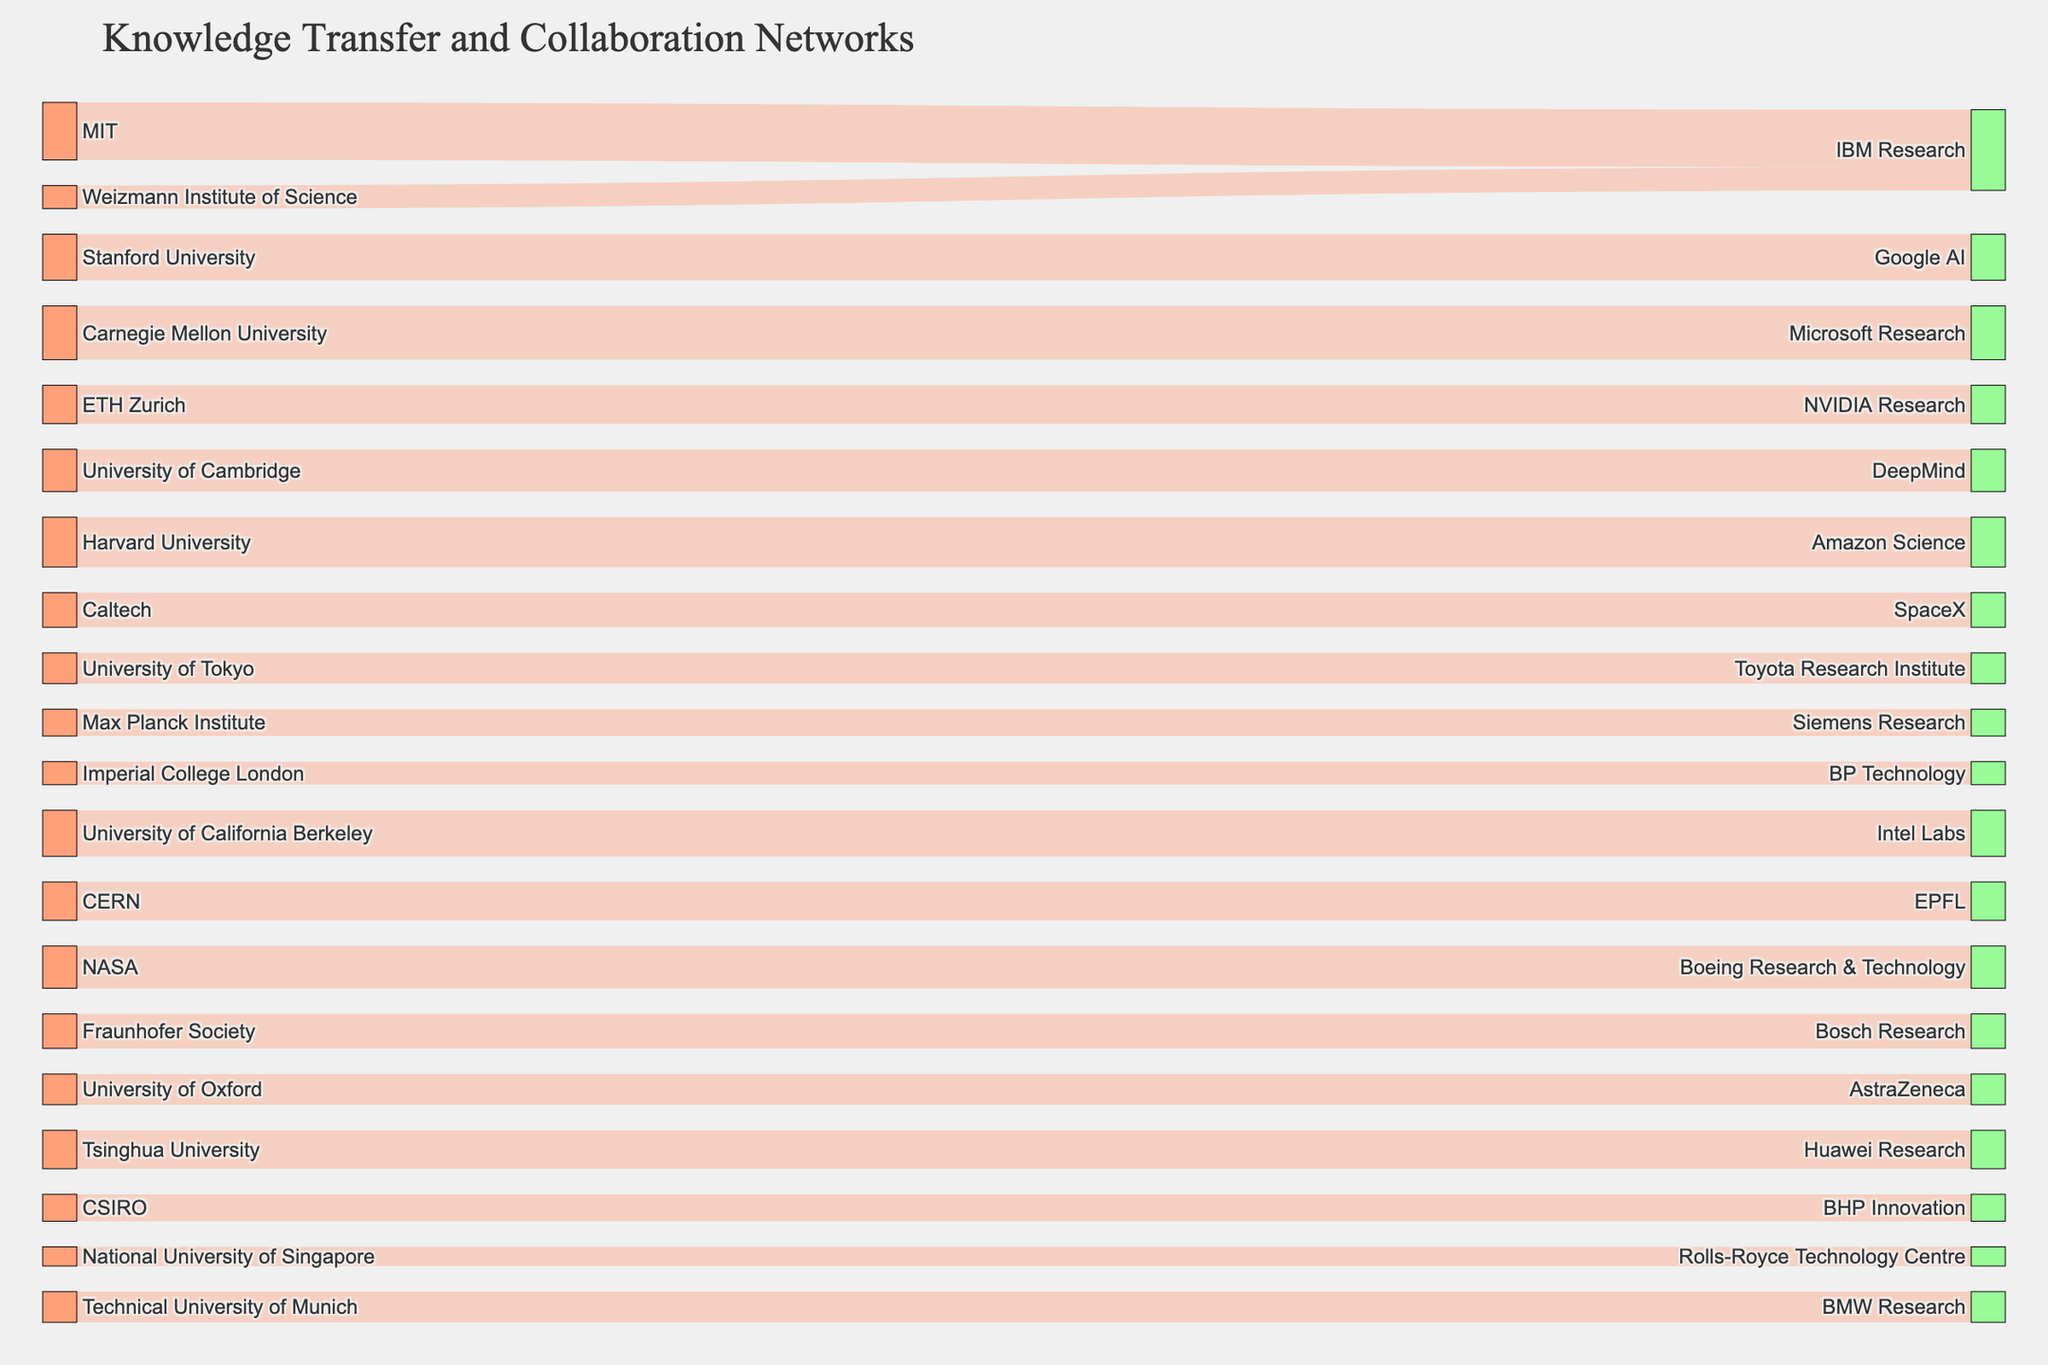How many total source institutions are represented in the diagram? Count the number of unique source institutions listed on the left side of the Sankey diagram. As per the dataset, there are 18 unique source institutions listed.
Answer: 18 How many total industry targets are represented in the diagram? Count the number of unique target industry leaders listed on the right side of the Sankey diagram. According to the dataset, there are 19 unique target organizations.
Answer: 19 Which source institution has the highest value of knowledge transfer to its target? Look at the width of the links connecting each source to its target. The widest link represents the highest value. According to the dataset, MIT to IBM Research has a value of 15, which is the highest.
Answer: MIT Which target institution receives the most knowledge transfers from different sources? Count the number of unique links connecting various sources to each target institution. IBM Research receives transfers from both MIT and Weizmann Institute of Science, making it the target with the most incoming links.
Answer: IBM Research What is the total value of knowledge transfer involving IBM Research as a target? Sum up the values of the links connected to IBM Research as a target. According to the dataset, these values are 15 (from MIT) and 6 (from Weizmann Institute of Science), summing to 21.
Answer: 21 What is the average value of knowledge transfer from MIT, Stanford University, and Carnegie Mellon University? Sum the values of the links from these three sources and divide by the number of sources. The values are 15 (MIT), 12 (Stanford University), and 14 (Carnegie Mellon University). The total is 41, and the average is 41/3 ≈ 13.67.
Answer: 13.67 How does the value of knowledge transfer from University of Tokyo to Toyota Research Institute compare to that from Caltech to SpaceX? Compare the respective values in the dataset. University of Tokyo to Toyota Research Institute has a value of 8, whereas Caltech to SpaceX has a value of 9. Thus, the latter is greater by 1.
Answer: Caltech to SpaceX is greater by 1 What's the combined value of the knowledge transfer from the University of California Berkeley and CERN? Sum the values of the links from these two sources. University of California Berkeley has a value of 12 and CERN has a value of 10, making the total 22.
Answer: 22 Which collaboration involves the smallest value of knowledge transfer? Look for the smallest value in the data and identify the corresponding source and target institutions. The smallest value is 5, from the National University of Singapore to Rolls-Royce Technology Centre.
Answer: National University of Singapore and Rolls-Royce Technology Centre What is the difference in the value of knowledge transfer between Harvard University and University of Oxford to their respective targets? Subtract the value of the knowledge transfer from University of Oxford to AstraZeneca from that of Harvard University to Amazon Science. Harvard University has a value of 13 and University of Oxford has a value of 8, so the difference is 13 - 8 = 5.
Answer: 5 